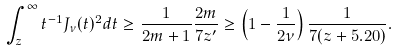<formula> <loc_0><loc_0><loc_500><loc_500>\int _ { z } ^ { \infty } t ^ { - 1 } J _ { \nu } ( t ) ^ { 2 } d t \geq \frac { 1 } { 2 m + 1 } \frac { 2 m } { 7 z ^ { \prime } } \geq \left ( 1 - \frac { 1 } { 2 \nu } \right ) \frac { 1 } { 7 ( z + 5 . 2 0 ) } .</formula> 